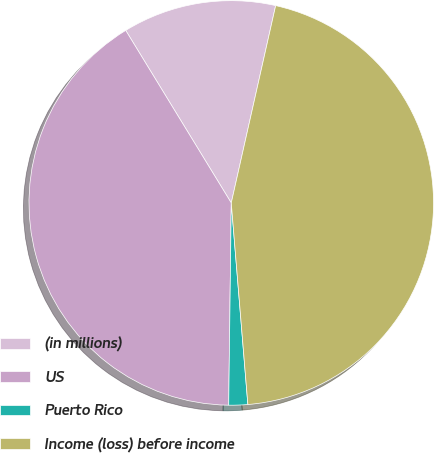Convert chart. <chart><loc_0><loc_0><loc_500><loc_500><pie_chart><fcel>(in millions)<fcel>US<fcel>Puerto Rico<fcel>Income (loss) before income<nl><fcel>12.26%<fcel>41.06%<fcel>1.51%<fcel>45.17%<nl></chart> 